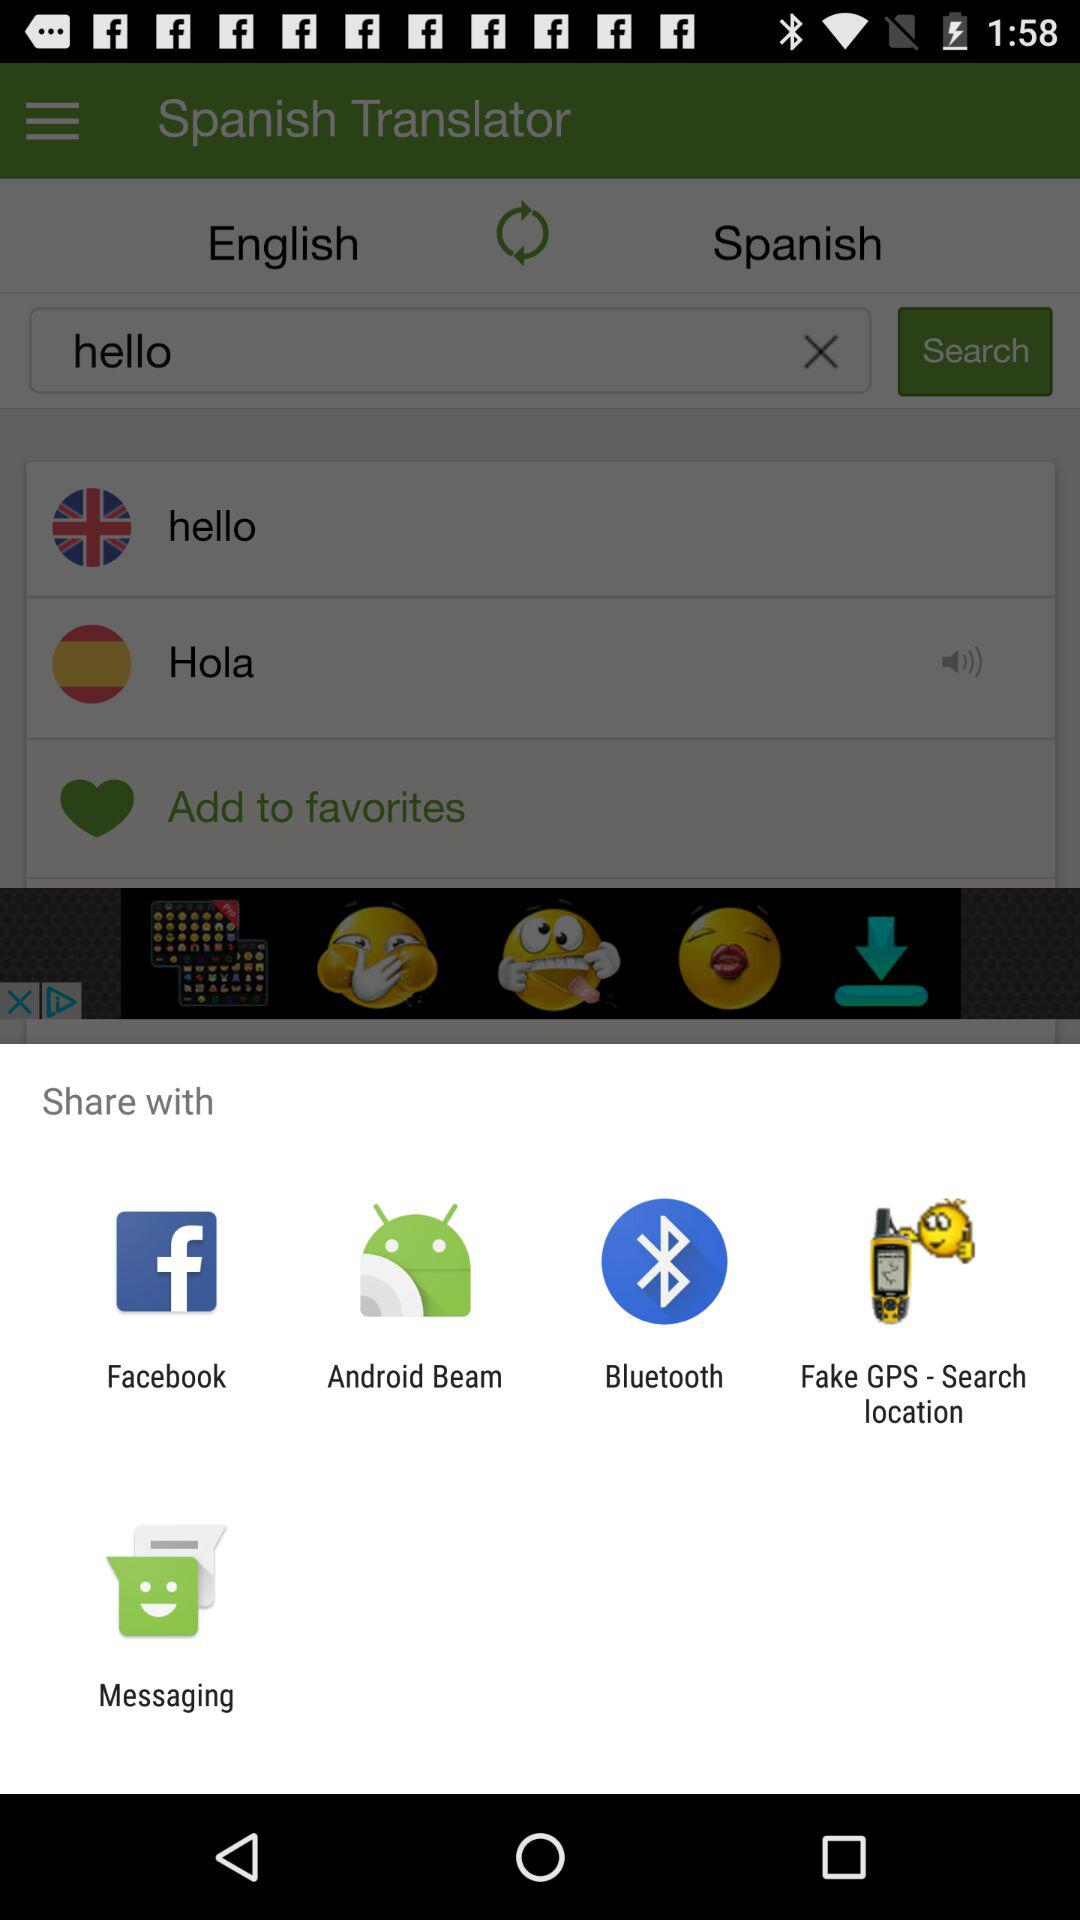What app can I use to share? You can use "Facebook", "Android Beam", "Bluetooth", "Fake GPS - Search location", and "Messaging". 